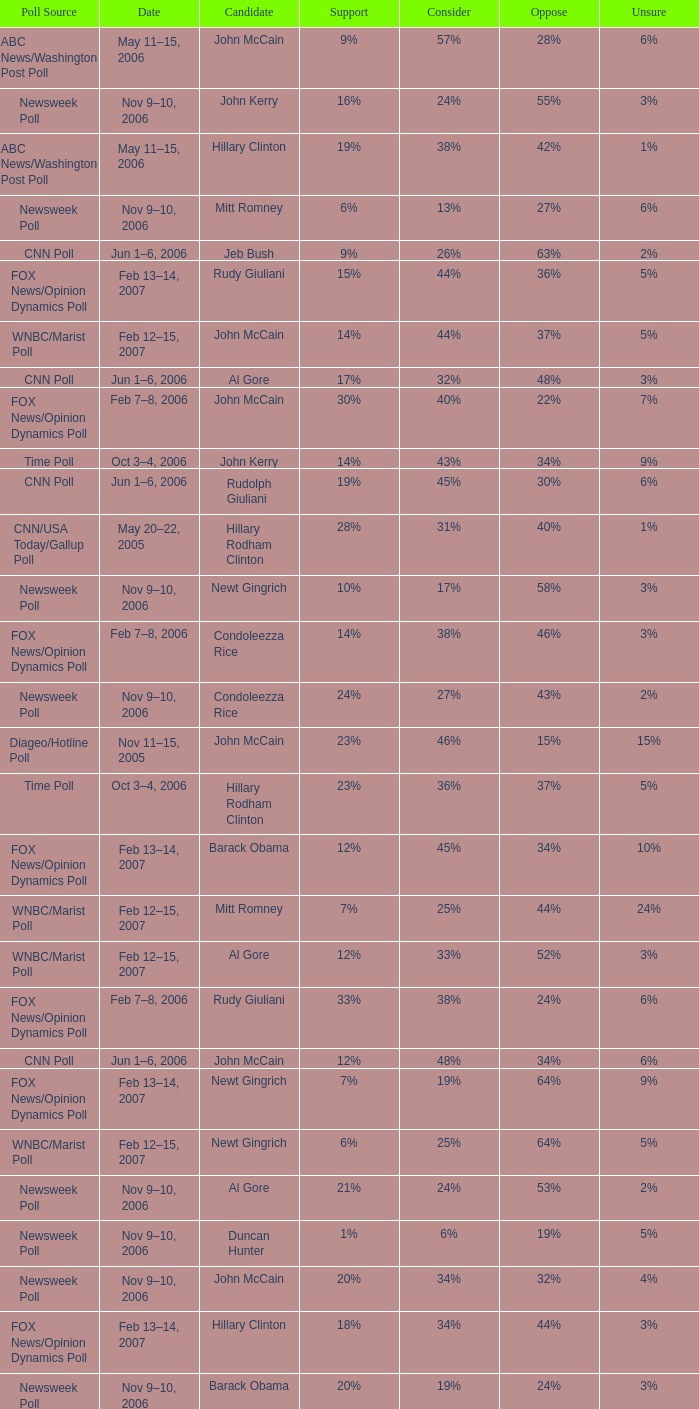What percentage of people said they would consider Rudy Giuliani as a candidate according to the Newsweek poll that showed 32% opposed him? 30%. 